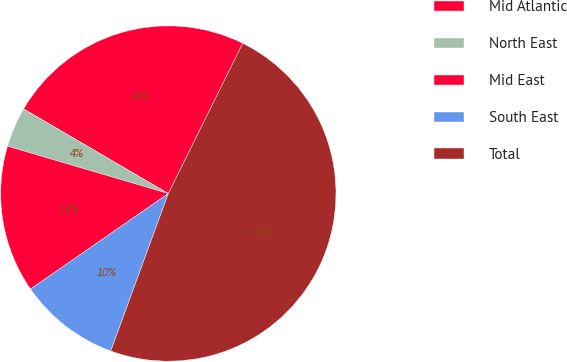<chart> <loc_0><loc_0><loc_500><loc_500><pie_chart><fcel>Mid Atlantic<fcel>North East<fcel>Mid East<fcel>South East<fcel>Total<nl><fcel>23.9%<fcel>3.86%<fcel>14.21%<fcel>9.77%<fcel>48.26%<nl></chart> 